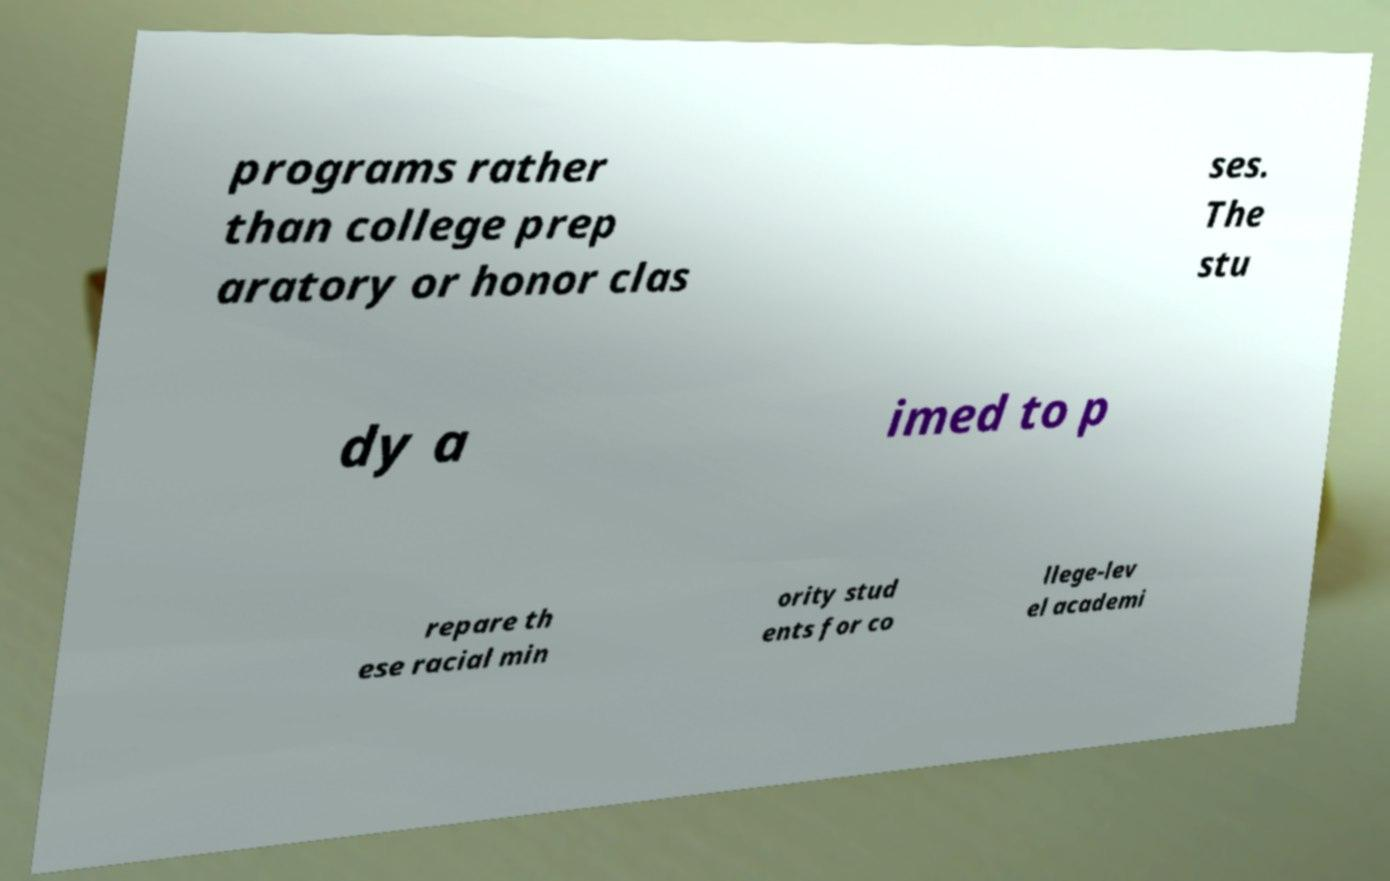Please read and relay the text visible in this image. What does it say? programs rather than college prep aratory or honor clas ses. The stu dy a imed to p repare th ese racial min ority stud ents for co llege-lev el academi 